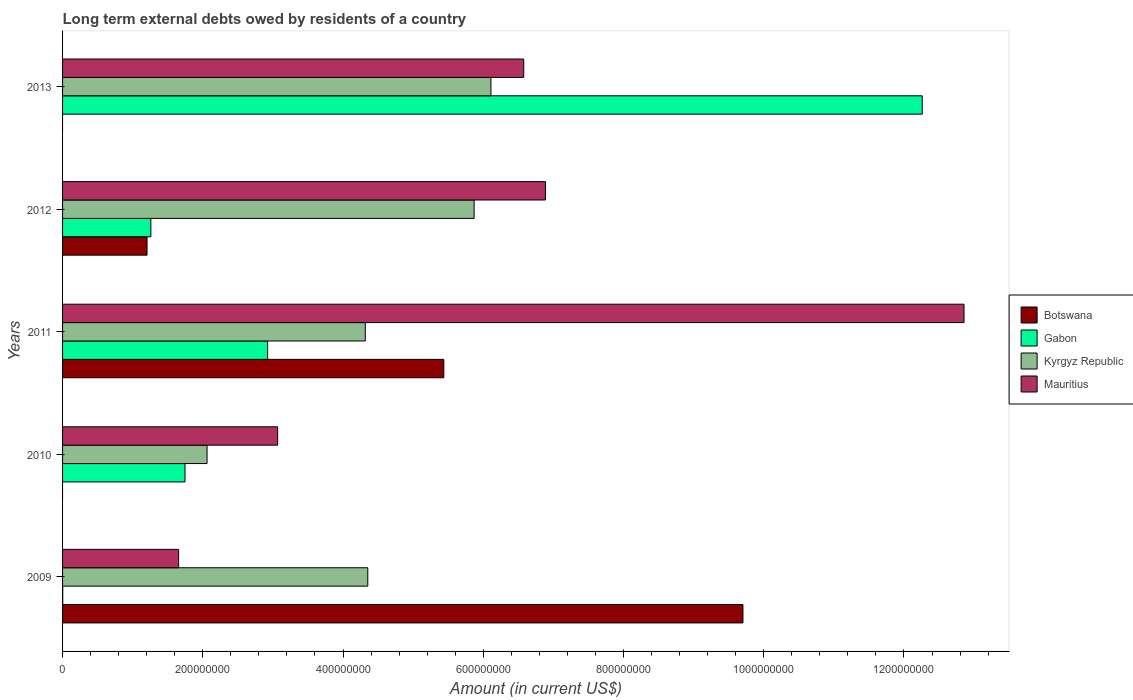How many groups of bars are there?
Offer a very short reply. 5. Are the number of bars on each tick of the Y-axis equal?
Make the answer very short. No. What is the amount of long-term external debts owed by residents in Kyrgyz Republic in 2011?
Offer a very short reply. 4.32e+08. Across all years, what is the maximum amount of long-term external debts owed by residents in Gabon?
Give a very brief answer. 1.23e+09. What is the total amount of long-term external debts owed by residents in Mauritius in the graph?
Offer a terse response. 3.10e+09. What is the difference between the amount of long-term external debts owed by residents in Mauritius in 2010 and that in 2011?
Make the answer very short. -9.79e+08. What is the difference between the amount of long-term external debts owed by residents in Botswana in 2010 and the amount of long-term external debts owed by residents in Gabon in 2011?
Your response must be concise. -2.92e+08. What is the average amount of long-term external debts owed by residents in Gabon per year?
Provide a short and direct response. 3.64e+08. In the year 2009, what is the difference between the amount of long-term external debts owed by residents in Botswana and amount of long-term external debts owed by residents in Gabon?
Your answer should be compact. 9.70e+08. In how many years, is the amount of long-term external debts owed by residents in Mauritius greater than 440000000 US$?
Keep it short and to the point. 3. What is the ratio of the amount of long-term external debts owed by residents in Mauritius in 2011 to that in 2012?
Provide a succinct answer. 1.87. Is the amount of long-term external debts owed by residents in Kyrgyz Republic in 2009 less than that in 2012?
Give a very brief answer. Yes. Is the difference between the amount of long-term external debts owed by residents in Botswana in 2011 and 2012 greater than the difference between the amount of long-term external debts owed by residents in Gabon in 2011 and 2012?
Give a very brief answer. Yes. What is the difference between the highest and the second highest amount of long-term external debts owed by residents in Botswana?
Give a very brief answer. 4.27e+08. What is the difference between the highest and the lowest amount of long-term external debts owed by residents in Kyrgyz Republic?
Offer a very short reply. 4.05e+08. In how many years, is the amount of long-term external debts owed by residents in Gabon greater than the average amount of long-term external debts owed by residents in Gabon taken over all years?
Offer a very short reply. 1. Is the sum of the amount of long-term external debts owed by residents in Mauritius in 2010 and 2013 greater than the maximum amount of long-term external debts owed by residents in Botswana across all years?
Provide a succinct answer. No. Are all the bars in the graph horizontal?
Provide a short and direct response. Yes. What is the difference between two consecutive major ticks on the X-axis?
Make the answer very short. 2.00e+08. Does the graph contain any zero values?
Make the answer very short. Yes. Does the graph contain grids?
Give a very brief answer. No. How many legend labels are there?
Give a very brief answer. 4. How are the legend labels stacked?
Offer a terse response. Vertical. What is the title of the graph?
Your answer should be compact. Long term external debts owed by residents of a country. Does "Saudi Arabia" appear as one of the legend labels in the graph?
Your answer should be compact. No. What is the label or title of the Y-axis?
Offer a terse response. Years. What is the Amount (in current US$) of Botswana in 2009?
Your answer should be very brief. 9.70e+08. What is the Amount (in current US$) of Gabon in 2009?
Your answer should be very brief. 2.35e+05. What is the Amount (in current US$) of Kyrgyz Republic in 2009?
Make the answer very short. 4.35e+08. What is the Amount (in current US$) of Mauritius in 2009?
Give a very brief answer. 1.65e+08. What is the Amount (in current US$) of Botswana in 2010?
Ensure brevity in your answer.  0. What is the Amount (in current US$) in Gabon in 2010?
Give a very brief answer. 1.75e+08. What is the Amount (in current US$) in Kyrgyz Republic in 2010?
Offer a very short reply. 2.06e+08. What is the Amount (in current US$) of Mauritius in 2010?
Keep it short and to the point. 3.07e+08. What is the Amount (in current US$) of Botswana in 2011?
Your response must be concise. 5.44e+08. What is the Amount (in current US$) of Gabon in 2011?
Your response must be concise. 2.92e+08. What is the Amount (in current US$) of Kyrgyz Republic in 2011?
Keep it short and to the point. 4.32e+08. What is the Amount (in current US$) of Mauritius in 2011?
Your response must be concise. 1.29e+09. What is the Amount (in current US$) in Botswana in 2012?
Provide a succinct answer. 1.20e+08. What is the Amount (in current US$) of Gabon in 2012?
Give a very brief answer. 1.26e+08. What is the Amount (in current US$) of Kyrgyz Republic in 2012?
Your answer should be compact. 5.87e+08. What is the Amount (in current US$) of Mauritius in 2012?
Keep it short and to the point. 6.89e+08. What is the Amount (in current US$) of Gabon in 2013?
Provide a short and direct response. 1.23e+09. What is the Amount (in current US$) of Kyrgyz Republic in 2013?
Provide a succinct answer. 6.11e+08. What is the Amount (in current US$) of Mauritius in 2013?
Your answer should be compact. 6.58e+08. Across all years, what is the maximum Amount (in current US$) in Botswana?
Offer a very short reply. 9.70e+08. Across all years, what is the maximum Amount (in current US$) of Gabon?
Provide a succinct answer. 1.23e+09. Across all years, what is the maximum Amount (in current US$) in Kyrgyz Republic?
Your answer should be compact. 6.11e+08. Across all years, what is the maximum Amount (in current US$) in Mauritius?
Provide a succinct answer. 1.29e+09. Across all years, what is the minimum Amount (in current US$) of Botswana?
Your answer should be compact. 0. Across all years, what is the minimum Amount (in current US$) of Gabon?
Offer a very short reply. 2.35e+05. Across all years, what is the minimum Amount (in current US$) of Kyrgyz Republic?
Give a very brief answer. 2.06e+08. Across all years, what is the minimum Amount (in current US$) in Mauritius?
Provide a succinct answer. 1.65e+08. What is the total Amount (in current US$) in Botswana in the graph?
Ensure brevity in your answer.  1.63e+09. What is the total Amount (in current US$) of Gabon in the graph?
Keep it short and to the point. 1.82e+09. What is the total Amount (in current US$) in Kyrgyz Republic in the graph?
Offer a very short reply. 2.27e+09. What is the total Amount (in current US$) in Mauritius in the graph?
Offer a very short reply. 3.10e+09. What is the difference between the Amount (in current US$) of Gabon in 2009 and that in 2010?
Keep it short and to the point. -1.74e+08. What is the difference between the Amount (in current US$) of Kyrgyz Republic in 2009 and that in 2010?
Your answer should be very brief. 2.29e+08. What is the difference between the Amount (in current US$) of Mauritius in 2009 and that in 2010?
Provide a succinct answer. -1.41e+08. What is the difference between the Amount (in current US$) in Botswana in 2009 and that in 2011?
Keep it short and to the point. 4.27e+08. What is the difference between the Amount (in current US$) in Gabon in 2009 and that in 2011?
Your answer should be compact. -2.92e+08. What is the difference between the Amount (in current US$) of Kyrgyz Republic in 2009 and that in 2011?
Keep it short and to the point. 3.60e+06. What is the difference between the Amount (in current US$) of Mauritius in 2009 and that in 2011?
Offer a very short reply. -1.12e+09. What is the difference between the Amount (in current US$) of Botswana in 2009 and that in 2012?
Keep it short and to the point. 8.50e+08. What is the difference between the Amount (in current US$) of Gabon in 2009 and that in 2012?
Your answer should be very brief. -1.26e+08. What is the difference between the Amount (in current US$) of Kyrgyz Republic in 2009 and that in 2012?
Provide a short and direct response. -1.52e+08. What is the difference between the Amount (in current US$) of Mauritius in 2009 and that in 2012?
Provide a short and direct response. -5.23e+08. What is the difference between the Amount (in current US$) of Gabon in 2009 and that in 2013?
Make the answer very short. -1.23e+09. What is the difference between the Amount (in current US$) in Kyrgyz Republic in 2009 and that in 2013?
Your response must be concise. -1.76e+08. What is the difference between the Amount (in current US$) of Mauritius in 2009 and that in 2013?
Offer a very short reply. -4.92e+08. What is the difference between the Amount (in current US$) of Gabon in 2010 and that in 2011?
Your answer should be compact. -1.18e+08. What is the difference between the Amount (in current US$) in Kyrgyz Republic in 2010 and that in 2011?
Offer a very short reply. -2.26e+08. What is the difference between the Amount (in current US$) of Mauritius in 2010 and that in 2011?
Provide a short and direct response. -9.79e+08. What is the difference between the Amount (in current US$) of Gabon in 2010 and that in 2012?
Ensure brevity in your answer.  4.87e+07. What is the difference between the Amount (in current US$) in Kyrgyz Republic in 2010 and that in 2012?
Ensure brevity in your answer.  -3.81e+08. What is the difference between the Amount (in current US$) of Mauritius in 2010 and that in 2012?
Your response must be concise. -3.82e+08. What is the difference between the Amount (in current US$) in Gabon in 2010 and that in 2013?
Provide a succinct answer. -1.05e+09. What is the difference between the Amount (in current US$) of Kyrgyz Republic in 2010 and that in 2013?
Offer a terse response. -4.05e+08. What is the difference between the Amount (in current US$) of Mauritius in 2010 and that in 2013?
Your response must be concise. -3.51e+08. What is the difference between the Amount (in current US$) of Botswana in 2011 and that in 2012?
Provide a short and direct response. 4.23e+08. What is the difference between the Amount (in current US$) of Gabon in 2011 and that in 2012?
Provide a succinct answer. 1.67e+08. What is the difference between the Amount (in current US$) in Kyrgyz Republic in 2011 and that in 2012?
Give a very brief answer. -1.55e+08. What is the difference between the Amount (in current US$) in Mauritius in 2011 and that in 2012?
Your response must be concise. 5.97e+08. What is the difference between the Amount (in current US$) of Gabon in 2011 and that in 2013?
Provide a short and direct response. -9.34e+08. What is the difference between the Amount (in current US$) in Kyrgyz Republic in 2011 and that in 2013?
Your response must be concise. -1.79e+08. What is the difference between the Amount (in current US$) of Mauritius in 2011 and that in 2013?
Keep it short and to the point. 6.28e+08. What is the difference between the Amount (in current US$) in Gabon in 2012 and that in 2013?
Ensure brevity in your answer.  -1.10e+09. What is the difference between the Amount (in current US$) in Kyrgyz Republic in 2012 and that in 2013?
Provide a succinct answer. -2.39e+07. What is the difference between the Amount (in current US$) of Mauritius in 2012 and that in 2013?
Your answer should be very brief. 3.10e+07. What is the difference between the Amount (in current US$) of Botswana in 2009 and the Amount (in current US$) of Gabon in 2010?
Provide a short and direct response. 7.96e+08. What is the difference between the Amount (in current US$) in Botswana in 2009 and the Amount (in current US$) in Kyrgyz Republic in 2010?
Your answer should be compact. 7.64e+08. What is the difference between the Amount (in current US$) in Botswana in 2009 and the Amount (in current US$) in Mauritius in 2010?
Give a very brief answer. 6.64e+08. What is the difference between the Amount (in current US$) of Gabon in 2009 and the Amount (in current US$) of Kyrgyz Republic in 2010?
Ensure brevity in your answer.  -2.06e+08. What is the difference between the Amount (in current US$) of Gabon in 2009 and the Amount (in current US$) of Mauritius in 2010?
Give a very brief answer. -3.07e+08. What is the difference between the Amount (in current US$) of Kyrgyz Republic in 2009 and the Amount (in current US$) of Mauritius in 2010?
Keep it short and to the point. 1.29e+08. What is the difference between the Amount (in current US$) in Botswana in 2009 and the Amount (in current US$) in Gabon in 2011?
Offer a very short reply. 6.78e+08. What is the difference between the Amount (in current US$) of Botswana in 2009 and the Amount (in current US$) of Kyrgyz Republic in 2011?
Ensure brevity in your answer.  5.39e+08. What is the difference between the Amount (in current US$) in Botswana in 2009 and the Amount (in current US$) in Mauritius in 2011?
Offer a terse response. -3.15e+08. What is the difference between the Amount (in current US$) in Gabon in 2009 and the Amount (in current US$) in Kyrgyz Republic in 2011?
Keep it short and to the point. -4.31e+08. What is the difference between the Amount (in current US$) in Gabon in 2009 and the Amount (in current US$) in Mauritius in 2011?
Your response must be concise. -1.29e+09. What is the difference between the Amount (in current US$) in Kyrgyz Republic in 2009 and the Amount (in current US$) in Mauritius in 2011?
Provide a short and direct response. -8.50e+08. What is the difference between the Amount (in current US$) in Botswana in 2009 and the Amount (in current US$) in Gabon in 2012?
Your response must be concise. 8.44e+08. What is the difference between the Amount (in current US$) of Botswana in 2009 and the Amount (in current US$) of Kyrgyz Republic in 2012?
Provide a short and direct response. 3.83e+08. What is the difference between the Amount (in current US$) in Botswana in 2009 and the Amount (in current US$) in Mauritius in 2012?
Ensure brevity in your answer.  2.82e+08. What is the difference between the Amount (in current US$) of Gabon in 2009 and the Amount (in current US$) of Kyrgyz Republic in 2012?
Offer a very short reply. -5.87e+08. What is the difference between the Amount (in current US$) of Gabon in 2009 and the Amount (in current US$) of Mauritius in 2012?
Keep it short and to the point. -6.88e+08. What is the difference between the Amount (in current US$) of Kyrgyz Republic in 2009 and the Amount (in current US$) of Mauritius in 2012?
Make the answer very short. -2.53e+08. What is the difference between the Amount (in current US$) in Botswana in 2009 and the Amount (in current US$) in Gabon in 2013?
Offer a terse response. -2.56e+08. What is the difference between the Amount (in current US$) in Botswana in 2009 and the Amount (in current US$) in Kyrgyz Republic in 2013?
Ensure brevity in your answer.  3.59e+08. What is the difference between the Amount (in current US$) of Botswana in 2009 and the Amount (in current US$) of Mauritius in 2013?
Provide a succinct answer. 3.13e+08. What is the difference between the Amount (in current US$) of Gabon in 2009 and the Amount (in current US$) of Kyrgyz Republic in 2013?
Your answer should be very brief. -6.11e+08. What is the difference between the Amount (in current US$) of Gabon in 2009 and the Amount (in current US$) of Mauritius in 2013?
Provide a short and direct response. -6.57e+08. What is the difference between the Amount (in current US$) in Kyrgyz Republic in 2009 and the Amount (in current US$) in Mauritius in 2013?
Make the answer very short. -2.22e+08. What is the difference between the Amount (in current US$) of Gabon in 2010 and the Amount (in current US$) of Kyrgyz Republic in 2011?
Keep it short and to the point. -2.57e+08. What is the difference between the Amount (in current US$) of Gabon in 2010 and the Amount (in current US$) of Mauritius in 2011?
Your answer should be very brief. -1.11e+09. What is the difference between the Amount (in current US$) of Kyrgyz Republic in 2010 and the Amount (in current US$) of Mauritius in 2011?
Your answer should be compact. -1.08e+09. What is the difference between the Amount (in current US$) of Gabon in 2010 and the Amount (in current US$) of Kyrgyz Republic in 2012?
Ensure brevity in your answer.  -4.12e+08. What is the difference between the Amount (in current US$) of Gabon in 2010 and the Amount (in current US$) of Mauritius in 2012?
Your answer should be very brief. -5.14e+08. What is the difference between the Amount (in current US$) in Kyrgyz Republic in 2010 and the Amount (in current US$) in Mauritius in 2012?
Your response must be concise. -4.83e+08. What is the difference between the Amount (in current US$) of Gabon in 2010 and the Amount (in current US$) of Kyrgyz Republic in 2013?
Your response must be concise. -4.36e+08. What is the difference between the Amount (in current US$) of Gabon in 2010 and the Amount (in current US$) of Mauritius in 2013?
Your answer should be compact. -4.83e+08. What is the difference between the Amount (in current US$) of Kyrgyz Republic in 2010 and the Amount (in current US$) of Mauritius in 2013?
Offer a very short reply. -4.52e+08. What is the difference between the Amount (in current US$) of Botswana in 2011 and the Amount (in current US$) of Gabon in 2012?
Offer a very short reply. 4.18e+08. What is the difference between the Amount (in current US$) in Botswana in 2011 and the Amount (in current US$) in Kyrgyz Republic in 2012?
Offer a very short reply. -4.33e+07. What is the difference between the Amount (in current US$) in Botswana in 2011 and the Amount (in current US$) in Mauritius in 2012?
Give a very brief answer. -1.45e+08. What is the difference between the Amount (in current US$) in Gabon in 2011 and the Amount (in current US$) in Kyrgyz Republic in 2012?
Make the answer very short. -2.95e+08. What is the difference between the Amount (in current US$) in Gabon in 2011 and the Amount (in current US$) in Mauritius in 2012?
Your answer should be compact. -3.96e+08. What is the difference between the Amount (in current US$) in Kyrgyz Republic in 2011 and the Amount (in current US$) in Mauritius in 2012?
Provide a succinct answer. -2.57e+08. What is the difference between the Amount (in current US$) in Botswana in 2011 and the Amount (in current US$) in Gabon in 2013?
Offer a terse response. -6.82e+08. What is the difference between the Amount (in current US$) of Botswana in 2011 and the Amount (in current US$) of Kyrgyz Republic in 2013?
Your answer should be compact. -6.72e+07. What is the difference between the Amount (in current US$) of Botswana in 2011 and the Amount (in current US$) of Mauritius in 2013?
Provide a short and direct response. -1.14e+08. What is the difference between the Amount (in current US$) of Gabon in 2011 and the Amount (in current US$) of Kyrgyz Republic in 2013?
Your answer should be very brief. -3.18e+08. What is the difference between the Amount (in current US$) of Gabon in 2011 and the Amount (in current US$) of Mauritius in 2013?
Your response must be concise. -3.65e+08. What is the difference between the Amount (in current US$) in Kyrgyz Republic in 2011 and the Amount (in current US$) in Mauritius in 2013?
Keep it short and to the point. -2.26e+08. What is the difference between the Amount (in current US$) in Botswana in 2012 and the Amount (in current US$) in Gabon in 2013?
Your response must be concise. -1.11e+09. What is the difference between the Amount (in current US$) of Botswana in 2012 and the Amount (in current US$) of Kyrgyz Republic in 2013?
Provide a short and direct response. -4.90e+08. What is the difference between the Amount (in current US$) in Botswana in 2012 and the Amount (in current US$) in Mauritius in 2013?
Your answer should be compact. -5.37e+08. What is the difference between the Amount (in current US$) in Gabon in 2012 and the Amount (in current US$) in Kyrgyz Republic in 2013?
Offer a very short reply. -4.85e+08. What is the difference between the Amount (in current US$) in Gabon in 2012 and the Amount (in current US$) in Mauritius in 2013?
Make the answer very short. -5.32e+08. What is the difference between the Amount (in current US$) in Kyrgyz Republic in 2012 and the Amount (in current US$) in Mauritius in 2013?
Your answer should be compact. -7.07e+07. What is the average Amount (in current US$) of Botswana per year?
Your answer should be compact. 3.27e+08. What is the average Amount (in current US$) in Gabon per year?
Your answer should be compact. 3.64e+08. What is the average Amount (in current US$) in Kyrgyz Republic per year?
Provide a short and direct response. 4.54e+08. What is the average Amount (in current US$) in Mauritius per year?
Your answer should be very brief. 6.21e+08. In the year 2009, what is the difference between the Amount (in current US$) of Botswana and Amount (in current US$) of Gabon?
Keep it short and to the point. 9.70e+08. In the year 2009, what is the difference between the Amount (in current US$) in Botswana and Amount (in current US$) in Kyrgyz Republic?
Your response must be concise. 5.35e+08. In the year 2009, what is the difference between the Amount (in current US$) in Botswana and Amount (in current US$) in Mauritius?
Keep it short and to the point. 8.05e+08. In the year 2009, what is the difference between the Amount (in current US$) in Gabon and Amount (in current US$) in Kyrgyz Republic?
Ensure brevity in your answer.  -4.35e+08. In the year 2009, what is the difference between the Amount (in current US$) in Gabon and Amount (in current US$) in Mauritius?
Provide a succinct answer. -1.65e+08. In the year 2009, what is the difference between the Amount (in current US$) of Kyrgyz Republic and Amount (in current US$) of Mauritius?
Offer a very short reply. 2.70e+08. In the year 2010, what is the difference between the Amount (in current US$) in Gabon and Amount (in current US$) in Kyrgyz Republic?
Your answer should be compact. -3.15e+07. In the year 2010, what is the difference between the Amount (in current US$) of Gabon and Amount (in current US$) of Mauritius?
Your response must be concise. -1.32e+08. In the year 2010, what is the difference between the Amount (in current US$) in Kyrgyz Republic and Amount (in current US$) in Mauritius?
Provide a succinct answer. -1.01e+08. In the year 2011, what is the difference between the Amount (in current US$) in Botswana and Amount (in current US$) in Gabon?
Offer a very short reply. 2.51e+08. In the year 2011, what is the difference between the Amount (in current US$) of Botswana and Amount (in current US$) of Kyrgyz Republic?
Provide a succinct answer. 1.12e+08. In the year 2011, what is the difference between the Amount (in current US$) of Botswana and Amount (in current US$) of Mauritius?
Keep it short and to the point. -7.42e+08. In the year 2011, what is the difference between the Amount (in current US$) in Gabon and Amount (in current US$) in Kyrgyz Republic?
Give a very brief answer. -1.39e+08. In the year 2011, what is the difference between the Amount (in current US$) of Gabon and Amount (in current US$) of Mauritius?
Keep it short and to the point. -9.93e+08. In the year 2011, what is the difference between the Amount (in current US$) in Kyrgyz Republic and Amount (in current US$) in Mauritius?
Keep it short and to the point. -8.54e+08. In the year 2012, what is the difference between the Amount (in current US$) in Botswana and Amount (in current US$) in Gabon?
Your response must be concise. -5.43e+06. In the year 2012, what is the difference between the Amount (in current US$) in Botswana and Amount (in current US$) in Kyrgyz Republic?
Provide a succinct answer. -4.66e+08. In the year 2012, what is the difference between the Amount (in current US$) of Botswana and Amount (in current US$) of Mauritius?
Provide a succinct answer. -5.68e+08. In the year 2012, what is the difference between the Amount (in current US$) of Gabon and Amount (in current US$) of Kyrgyz Republic?
Provide a succinct answer. -4.61e+08. In the year 2012, what is the difference between the Amount (in current US$) of Gabon and Amount (in current US$) of Mauritius?
Give a very brief answer. -5.63e+08. In the year 2012, what is the difference between the Amount (in current US$) in Kyrgyz Republic and Amount (in current US$) in Mauritius?
Keep it short and to the point. -1.02e+08. In the year 2013, what is the difference between the Amount (in current US$) of Gabon and Amount (in current US$) of Kyrgyz Republic?
Offer a very short reply. 6.15e+08. In the year 2013, what is the difference between the Amount (in current US$) of Gabon and Amount (in current US$) of Mauritius?
Ensure brevity in your answer.  5.68e+08. In the year 2013, what is the difference between the Amount (in current US$) in Kyrgyz Republic and Amount (in current US$) in Mauritius?
Give a very brief answer. -4.68e+07. What is the ratio of the Amount (in current US$) in Gabon in 2009 to that in 2010?
Make the answer very short. 0. What is the ratio of the Amount (in current US$) in Kyrgyz Republic in 2009 to that in 2010?
Offer a terse response. 2.11. What is the ratio of the Amount (in current US$) in Mauritius in 2009 to that in 2010?
Your answer should be compact. 0.54. What is the ratio of the Amount (in current US$) of Botswana in 2009 to that in 2011?
Make the answer very short. 1.78. What is the ratio of the Amount (in current US$) in Gabon in 2009 to that in 2011?
Ensure brevity in your answer.  0. What is the ratio of the Amount (in current US$) in Kyrgyz Republic in 2009 to that in 2011?
Give a very brief answer. 1.01. What is the ratio of the Amount (in current US$) of Mauritius in 2009 to that in 2011?
Your answer should be very brief. 0.13. What is the ratio of the Amount (in current US$) of Botswana in 2009 to that in 2012?
Your answer should be compact. 8.05. What is the ratio of the Amount (in current US$) of Gabon in 2009 to that in 2012?
Offer a terse response. 0. What is the ratio of the Amount (in current US$) of Kyrgyz Republic in 2009 to that in 2012?
Offer a terse response. 0.74. What is the ratio of the Amount (in current US$) in Mauritius in 2009 to that in 2012?
Your answer should be compact. 0.24. What is the ratio of the Amount (in current US$) of Kyrgyz Republic in 2009 to that in 2013?
Make the answer very short. 0.71. What is the ratio of the Amount (in current US$) of Mauritius in 2009 to that in 2013?
Your response must be concise. 0.25. What is the ratio of the Amount (in current US$) in Gabon in 2010 to that in 2011?
Ensure brevity in your answer.  0.6. What is the ratio of the Amount (in current US$) of Kyrgyz Republic in 2010 to that in 2011?
Ensure brevity in your answer.  0.48. What is the ratio of the Amount (in current US$) of Mauritius in 2010 to that in 2011?
Your answer should be very brief. 0.24. What is the ratio of the Amount (in current US$) of Gabon in 2010 to that in 2012?
Your answer should be compact. 1.39. What is the ratio of the Amount (in current US$) of Kyrgyz Republic in 2010 to that in 2012?
Your response must be concise. 0.35. What is the ratio of the Amount (in current US$) in Mauritius in 2010 to that in 2012?
Offer a terse response. 0.45. What is the ratio of the Amount (in current US$) of Gabon in 2010 to that in 2013?
Ensure brevity in your answer.  0.14. What is the ratio of the Amount (in current US$) of Kyrgyz Republic in 2010 to that in 2013?
Your answer should be very brief. 0.34. What is the ratio of the Amount (in current US$) in Mauritius in 2010 to that in 2013?
Keep it short and to the point. 0.47. What is the ratio of the Amount (in current US$) in Botswana in 2011 to that in 2012?
Provide a succinct answer. 4.51. What is the ratio of the Amount (in current US$) in Gabon in 2011 to that in 2012?
Keep it short and to the point. 2.32. What is the ratio of the Amount (in current US$) in Kyrgyz Republic in 2011 to that in 2012?
Give a very brief answer. 0.74. What is the ratio of the Amount (in current US$) in Mauritius in 2011 to that in 2012?
Keep it short and to the point. 1.87. What is the ratio of the Amount (in current US$) in Gabon in 2011 to that in 2013?
Provide a succinct answer. 0.24. What is the ratio of the Amount (in current US$) of Kyrgyz Republic in 2011 to that in 2013?
Your answer should be compact. 0.71. What is the ratio of the Amount (in current US$) in Mauritius in 2011 to that in 2013?
Your answer should be very brief. 1.95. What is the ratio of the Amount (in current US$) in Gabon in 2012 to that in 2013?
Make the answer very short. 0.1. What is the ratio of the Amount (in current US$) of Kyrgyz Republic in 2012 to that in 2013?
Your answer should be very brief. 0.96. What is the ratio of the Amount (in current US$) of Mauritius in 2012 to that in 2013?
Keep it short and to the point. 1.05. What is the difference between the highest and the second highest Amount (in current US$) in Botswana?
Your response must be concise. 4.27e+08. What is the difference between the highest and the second highest Amount (in current US$) in Gabon?
Your answer should be compact. 9.34e+08. What is the difference between the highest and the second highest Amount (in current US$) of Kyrgyz Republic?
Give a very brief answer. 2.39e+07. What is the difference between the highest and the second highest Amount (in current US$) in Mauritius?
Offer a terse response. 5.97e+08. What is the difference between the highest and the lowest Amount (in current US$) of Botswana?
Offer a very short reply. 9.70e+08. What is the difference between the highest and the lowest Amount (in current US$) in Gabon?
Offer a very short reply. 1.23e+09. What is the difference between the highest and the lowest Amount (in current US$) of Kyrgyz Republic?
Ensure brevity in your answer.  4.05e+08. What is the difference between the highest and the lowest Amount (in current US$) in Mauritius?
Provide a succinct answer. 1.12e+09. 